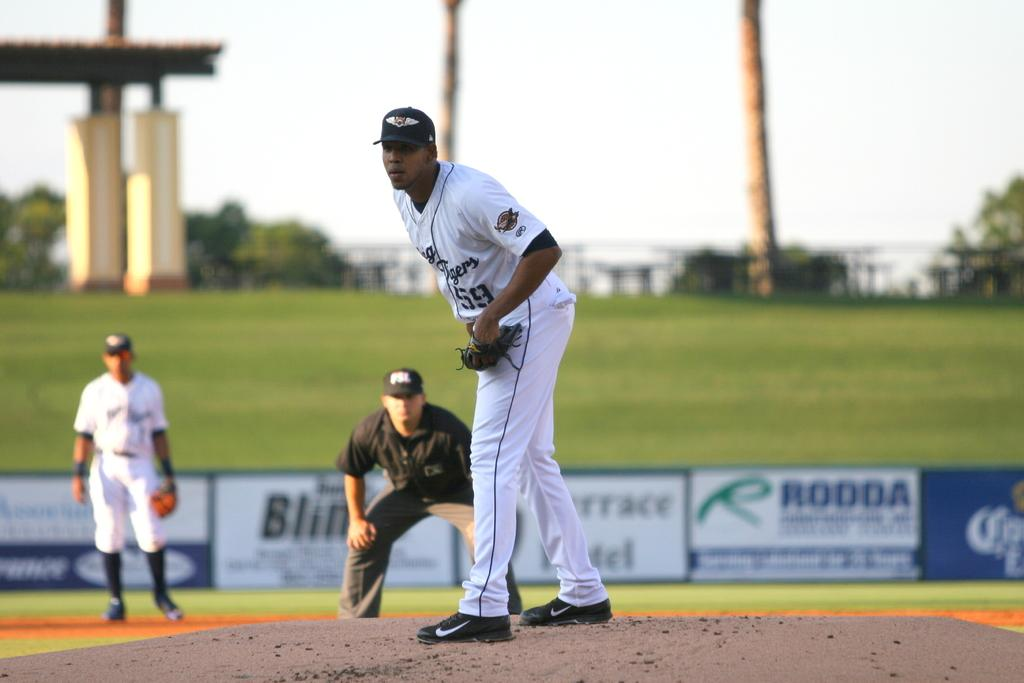Provide a one-sentence caption for the provided image. Two members of a baseball team and an umpire out on the field with advertisements such as Rodda in the background. 